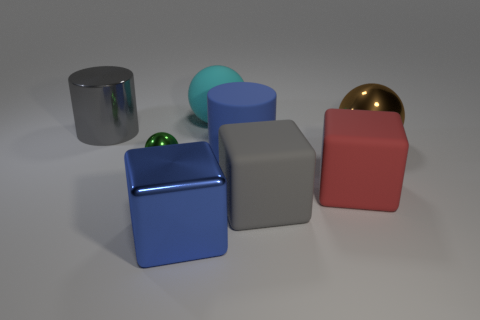Do the large blue metal object and the large gray thing that is in front of the rubber cylinder have the same shape?
Make the answer very short. Yes. What shape is the rubber object that is the same color as the big metal cylinder?
Give a very brief answer. Cube. Are there any big yellow spheres made of the same material as the small green ball?
Your response must be concise. No. What material is the big sphere that is on the left side of the large ball right of the cyan rubber sphere?
Provide a succinct answer. Rubber. What size is the ball on the right side of the large blue thing that is behind the gray rubber object left of the large shiny ball?
Provide a succinct answer. Large. How many other objects are there of the same shape as the tiny metal object?
Your response must be concise. 2. Is the color of the cube that is on the left side of the gray rubber block the same as the cylinder in front of the metal cylinder?
Give a very brief answer. Yes. What color is the matte cylinder that is the same size as the blue shiny cube?
Offer a very short reply. Blue. Are there any blocks that have the same color as the large rubber cylinder?
Offer a terse response. Yes. Is the size of the metal object that is on the right side of the cyan rubber object the same as the blue metallic cube?
Ensure brevity in your answer.  Yes. 